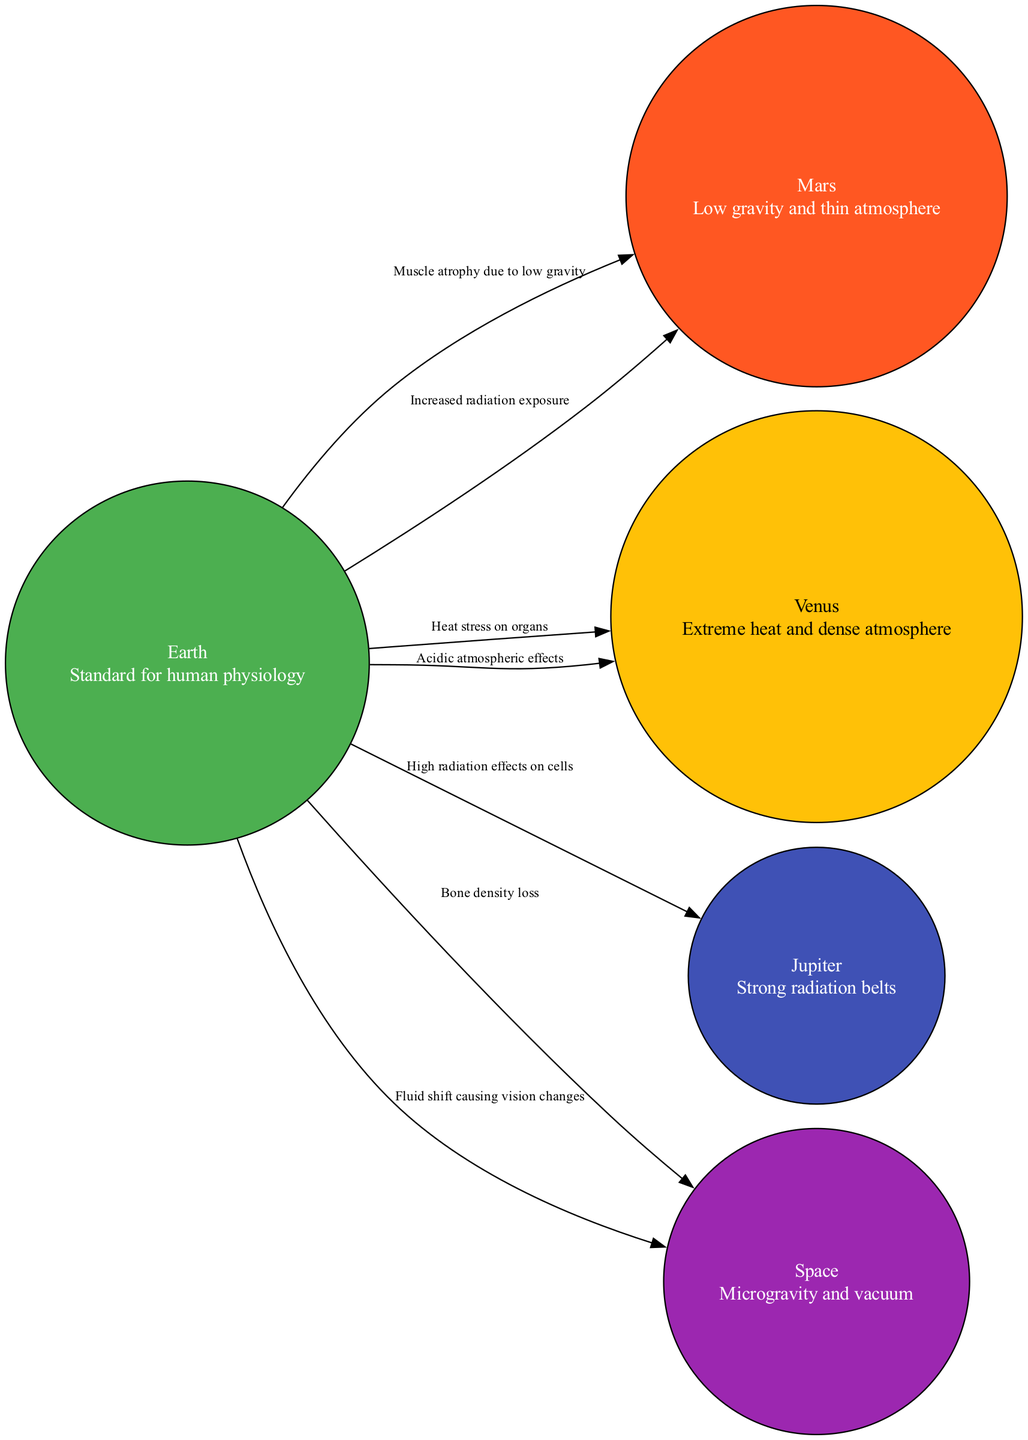What is the standard for human physiology depicted in the diagram? The diagram lists Earth as the standard for human physiology, indicated in the node description for Earth.
Answer: Earth How many nodes are present in the diagram? By counting the individual entities listed in the nodes section, there are five distinct nodes representing Earth, Mars, Venus, Jupiter, and Space.
Answer: 5 What are the effects on human physiology due to Mars? The edges from Earth to Mars indicate muscle atrophy due to low gravity and increased radiation exposure.
Answer: Muscle atrophy due to low gravity, Increased radiation exposure What effect does Venus have on human organs? The diagram shows the edges from Earth to Venus stating that there is heat stress on organs and acidic atmospheric effects impacting human physiology.
Answer: Heat stress on organs, Acidic atmospheric effects What relationship is indicated between Earth and Space? The diagram specifies edges that indicate bone density loss and fluid shift causing vision changes when comparing Earth to Space.
Answer: Bone density loss, Fluid shift causing vision changes Which planet is associated with strong radiation belts? The description under the node for Jupiter clearly states that it is associated with strong radiation belts affecting human physiology.
Answer: Jupiter How does the diagram depict the relationship between Earth and Jupiter? The edges connecting Earth to Jupiter explain the high radiation effects on cells, suggesting a detrimental relationship in terms of human physiology.
Answer: High radiation effects on cells What type of environment is represented by the node Space? The description for the node Space indicates that it represents microgravity and vacuum conditions that affect human physiology.
Answer: Microgravity and vacuum Which planet poses extreme heat conditions for humans? Looking at the information related to the Venus node, the diagram indicates extreme heat and dense atmosphere, posing a significant threat to human physiology.
Answer: Venus What is a significant physiological effect of Space on humans? The edges connecting Earth to Space highlight significant physiological effects such as bone density loss and fluid shift causing vision changes due to the microgravity environment.
Answer: Bone density loss, Fluid shift causing vision changes 